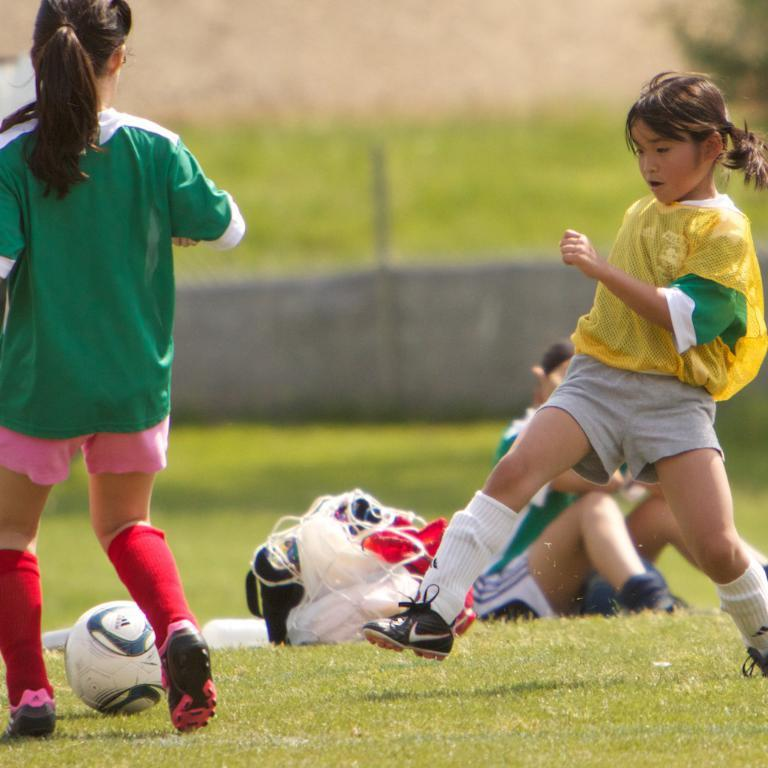How many girls are present in the image? There are two girls in the image. What activity are the girls engaged in? The girls are playing football. What is the setting of the image? There is a green field in the image. What type of fall can be seen in the image? There is no fall present in the image; it features two girls playing football on a green field. Who is the owner of the harbor in the image? There is no harbor present in the image. 